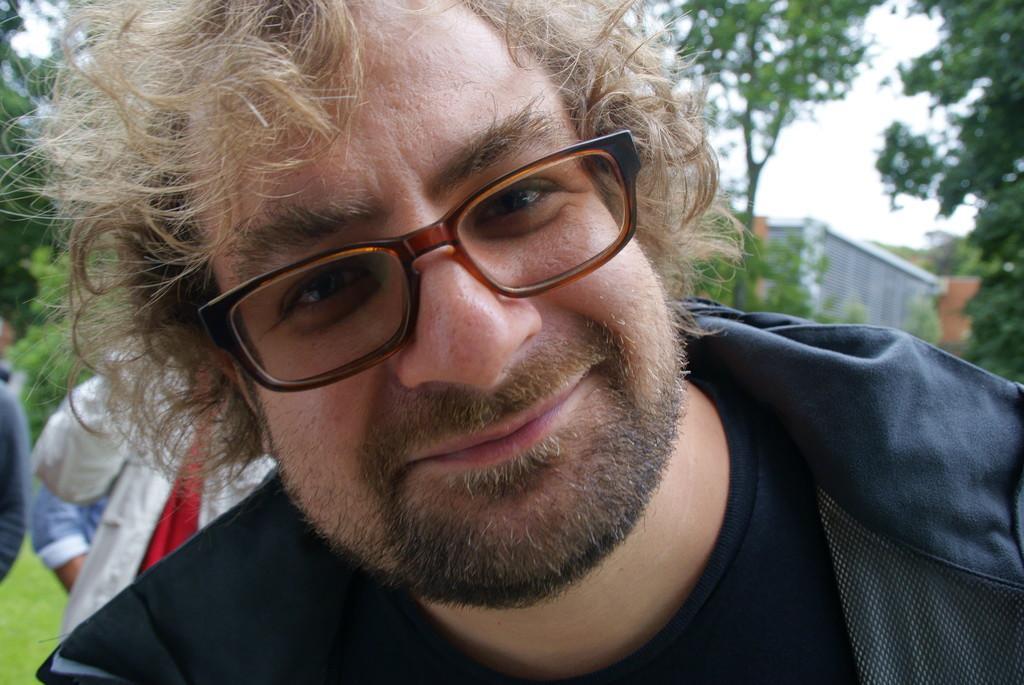Please provide a concise description of this image. In this image there is a person with a smile on his face, behind the person there are a few people standing on the surface of the grass. In the background there are trees, building and the sky. 